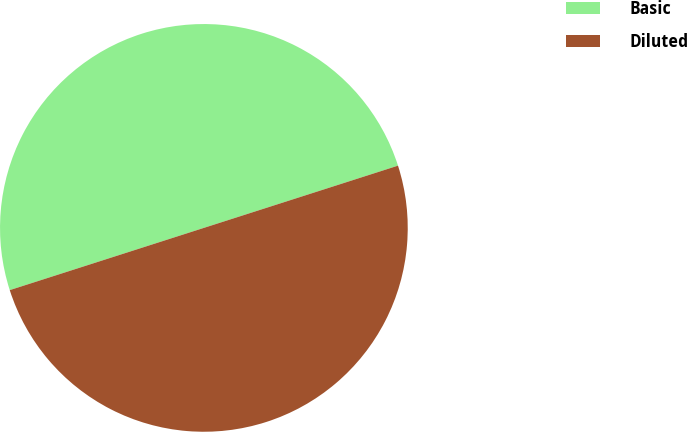<chart> <loc_0><loc_0><loc_500><loc_500><pie_chart><fcel>Basic<fcel>Diluted<nl><fcel>50.0%<fcel>50.0%<nl></chart> 